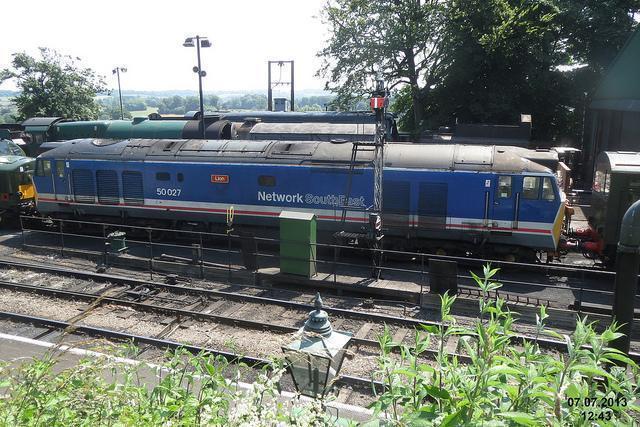What is the first number that appears on the train?
Answer the question by selecting the correct answer among the 4 following choices.
Options: Five, seven, eight, nine. Five. 